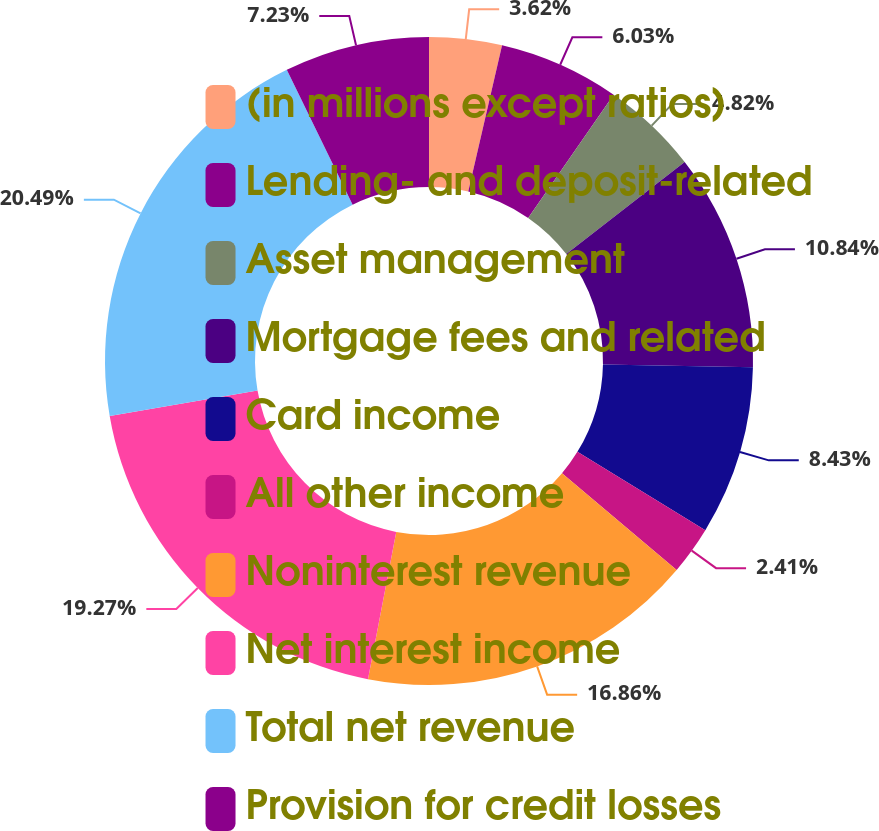Convert chart to OTSL. <chart><loc_0><loc_0><loc_500><loc_500><pie_chart><fcel>(in millions except ratios)<fcel>Lending- and deposit-related<fcel>Asset management<fcel>Mortgage fees and related<fcel>Card income<fcel>All other income<fcel>Noninterest revenue<fcel>Net interest income<fcel>Total net revenue<fcel>Provision for credit losses<nl><fcel>3.62%<fcel>6.03%<fcel>4.82%<fcel>10.84%<fcel>8.43%<fcel>2.41%<fcel>16.86%<fcel>19.27%<fcel>20.48%<fcel>7.23%<nl></chart> 